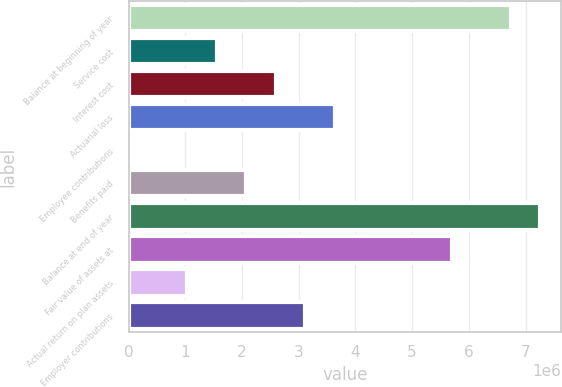<chart> <loc_0><loc_0><loc_500><loc_500><bar_chart><fcel>Balance at beginning of year<fcel>Service cost<fcel>Interest cost<fcel>Actuarial loss<fcel>Employee contributions<fcel>Benefits paid<fcel>Balance at end of year<fcel>Fair value of assets at<fcel>Actual return on plan assets<fcel>Employer contributions<nl><fcel>6.74368e+06<fcel>1.55687e+06<fcel>2.59423e+06<fcel>3.63159e+06<fcel>828<fcel>2.07555e+06<fcel>7.26236e+06<fcel>5.70632e+06<fcel>1.03819e+06<fcel>3.11291e+06<nl></chart> 